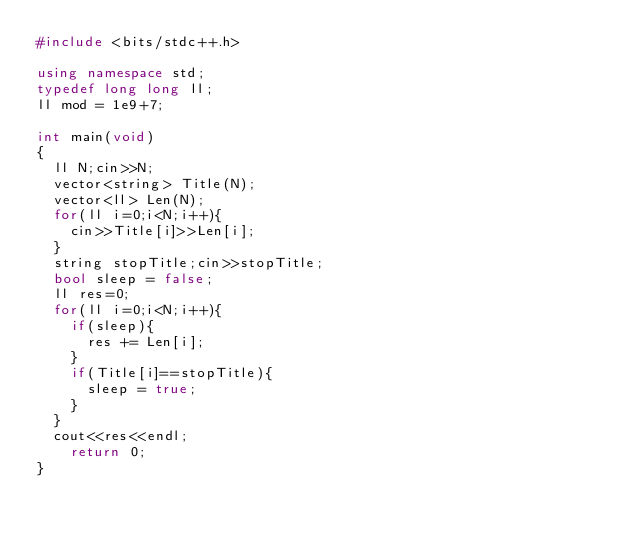Convert code to text. <code><loc_0><loc_0><loc_500><loc_500><_C++_>#include <bits/stdc++.h>

using namespace std;
typedef long long ll;
ll mod = 1e9+7;

int main(void)
{
  ll N;cin>>N;
  vector<string> Title(N);
  vector<ll> Len(N);
  for(ll i=0;i<N;i++){
    cin>>Title[i]>>Len[i];
  }
  string stopTitle;cin>>stopTitle;
  bool sleep = false;
  ll res=0;
  for(ll i=0;i<N;i++){
    if(sleep){
      res += Len[i];
    }
    if(Title[i]==stopTitle){
      sleep = true;
    }
  }
  cout<<res<<endl;
    return 0;
}</code> 